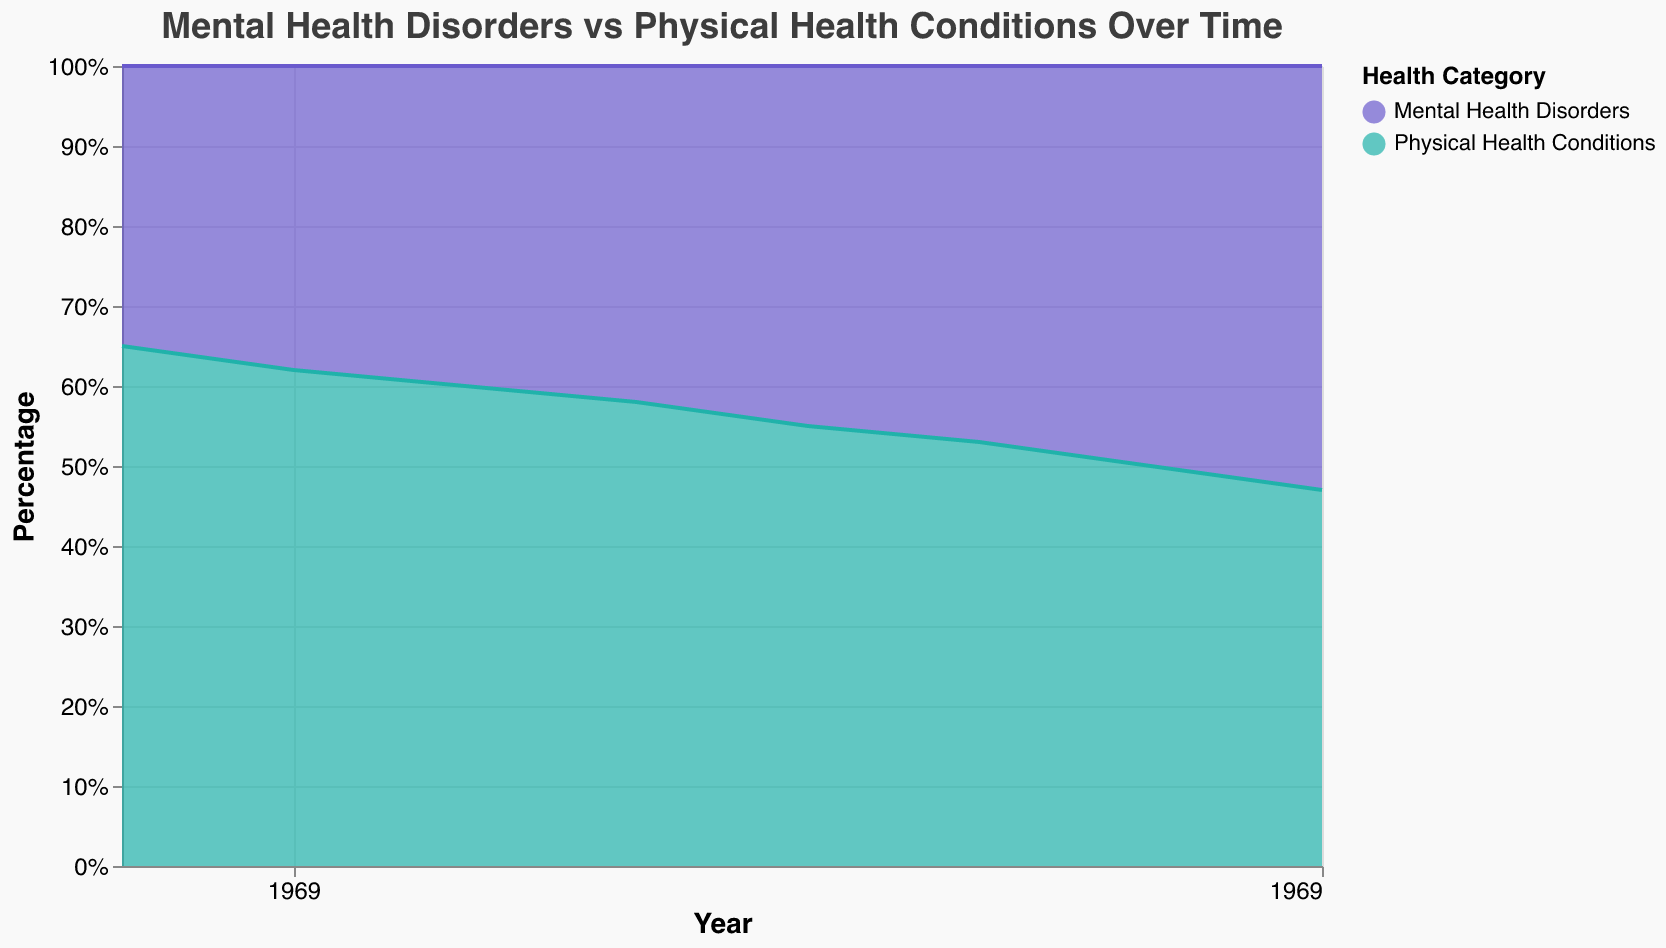How many years of data are represented in the figure? The figure's x-axis shows the years from 1990 to 2025. Counting all the individual years included, we get 1990, 1995, 2000, 2005, 2010, 2015, 2020, and 2025.
Answer: 8 What category had the lowest percentage in 1990? By looking at the figure, we see that in 1990 the percentage of Mental Health Disorders was 35% and Physical Health Conditions was 65%. The lowest percentage is 35%, which corresponds to Mental Health Disorders.
Answer: Mental Health Disorders How do the percentages of Mental Health Disorders and Physical Health Conditions compare in 2020? In 2020, the figure shows both categories at 50% each, indicating an equal distribution.
Answer: Equal What is the trend of Mental Health Disorders from 1990 to 2025? Observing the data for Mental Health Disorders in the figure from 1990 (35%) to 2025 (53%), we can see a consistent upward trend in its percentage over the years.
Answer: Increasing During which time period did Mental Health Disorders see the most significant increase? To determine the most significant increase, we need to look at the differences in percentages between consecutive time points. From 1990 to 1995, the increase was 3%, from 1995 to 2000 it was 2%, from 2000 to 2005 it was 2%, from 2005 to 2010 it was 3%, from 2010 to 2015 it was 2%, from 2015 to 2020 it was 3%, and from 2020 to 2025 it was 3%. All increases are relatively steady, with no single period having a more significant spike.
Answer: 1990-1995, 2005-2010, 2015-2020, 2020-2025 What is the difference in the percentage of Physical Health Conditions between 1990 and 2020? In 1990, the percentage of Physical Health Conditions was 65%. By 2020, it was 50%. The difference can thus be calculated as 65% - 50%, which yields 15%.
Answer: 15% Is there any year where the percentage of Physical Health Conditions is higher than 60%? Checking the data and the figure, we see that the percentage of Physical Health Conditions is higher than 60% in the year 1990 (65%) and 1995 (62%).
Answer: Yes Between which years did the percentages of Mental Health Disorders and Physical Health Conditions become equal? According to the figure, the percentages for Mental Health Disorders and Physical Health Conditions became equal at 50% in the year 2020. So, this equality happened between 2015 and 2020.
Answer: 2015-2020 